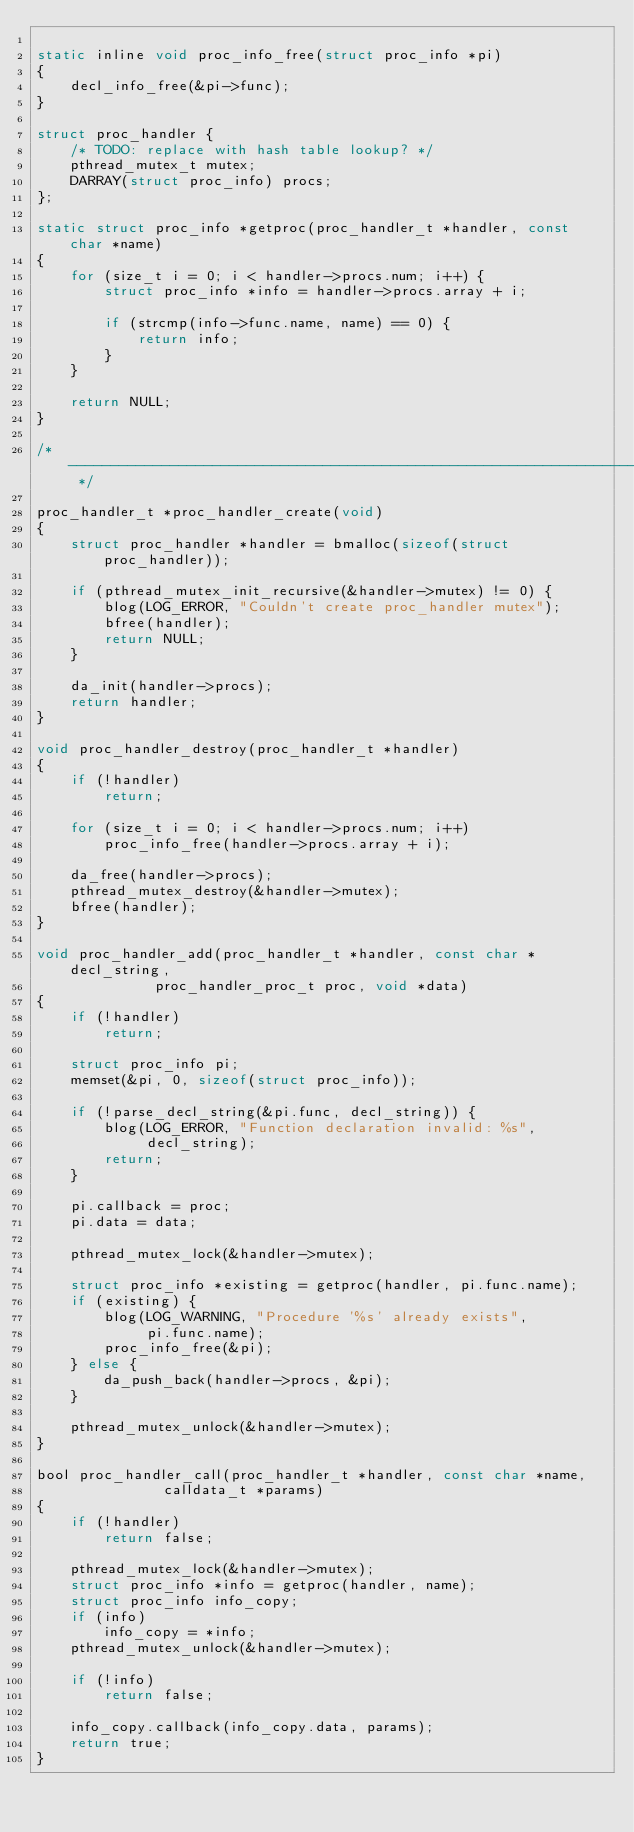<code> <loc_0><loc_0><loc_500><loc_500><_C_>
static inline void proc_info_free(struct proc_info *pi)
{
	decl_info_free(&pi->func);
}

struct proc_handler {
	/* TODO: replace with hash table lookup? */
	pthread_mutex_t mutex;
	DARRAY(struct proc_info) procs;
};

static struct proc_info *getproc(proc_handler_t *handler, const char *name)
{
	for (size_t i = 0; i < handler->procs.num; i++) {
		struct proc_info *info = handler->procs.array + i;

		if (strcmp(info->func.name, name) == 0) {
			return info;
		}
	}

	return NULL;
}

/* ------------------------------------------------------------------------- */

proc_handler_t *proc_handler_create(void)
{
	struct proc_handler *handler = bmalloc(sizeof(struct proc_handler));

	if (pthread_mutex_init_recursive(&handler->mutex) != 0) {
		blog(LOG_ERROR, "Couldn't create proc_handler mutex");
		bfree(handler);
		return NULL;
	}

	da_init(handler->procs);
	return handler;
}

void proc_handler_destroy(proc_handler_t *handler)
{
	if (!handler)
		return;

	for (size_t i = 0; i < handler->procs.num; i++)
		proc_info_free(handler->procs.array + i);

	da_free(handler->procs);
	pthread_mutex_destroy(&handler->mutex);
	bfree(handler);
}

void proc_handler_add(proc_handler_t *handler, const char *decl_string,
		      proc_handler_proc_t proc, void *data)
{
	if (!handler)
		return;

	struct proc_info pi;
	memset(&pi, 0, sizeof(struct proc_info));

	if (!parse_decl_string(&pi.func, decl_string)) {
		blog(LOG_ERROR, "Function declaration invalid: %s",
		     decl_string);
		return;
	}

	pi.callback = proc;
	pi.data = data;

	pthread_mutex_lock(&handler->mutex);

	struct proc_info *existing = getproc(handler, pi.func.name);
	if (existing) {
		blog(LOG_WARNING, "Procedure '%s' already exists",
		     pi.func.name);
		proc_info_free(&pi);
	} else {
		da_push_back(handler->procs, &pi);
	}

	pthread_mutex_unlock(&handler->mutex);
}

bool proc_handler_call(proc_handler_t *handler, const char *name,
		       calldata_t *params)
{
	if (!handler)
		return false;

	pthread_mutex_lock(&handler->mutex);
	struct proc_info *info = getproc(handler, name);
	struct proc_info info_copy;
	if (info)
		info_copy = *info;
	pthread_mutex_unlock(&handler->mutex);

	if (!info)
		return false;

	info_copy.callback(info_copy.data, params);
	return true;
}
</code> 